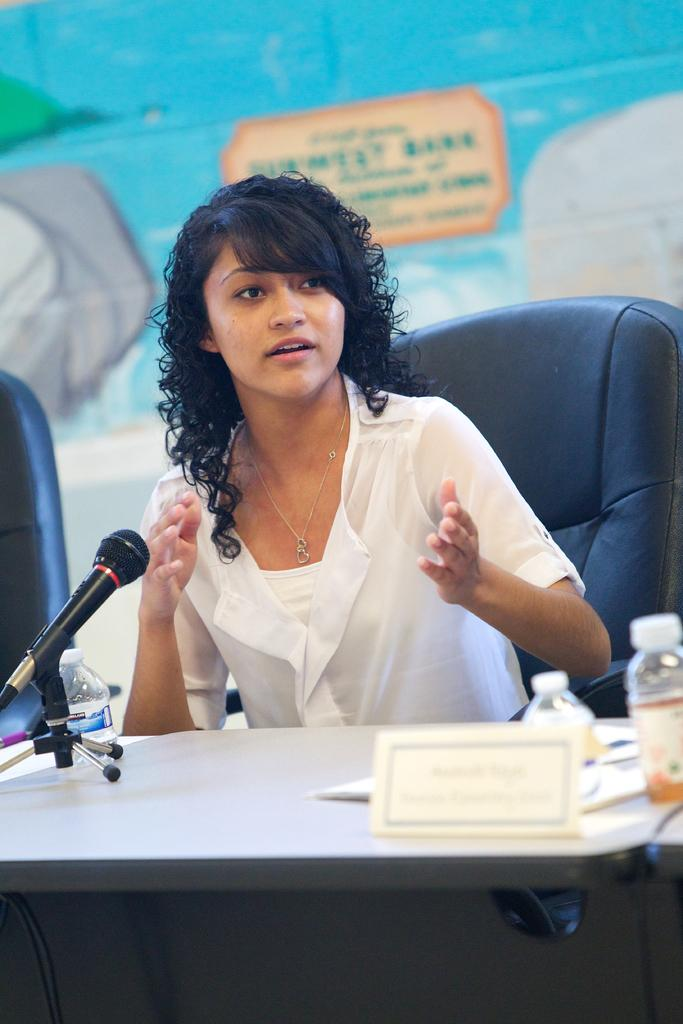Who is the main subject in the image? There is a woman in the image. What is the woman doing in the image? The woman is sitting on a chair. What is in front of the woman? There is a table in front of the woman. What objects can be seen on the table? There are 3 bottles and a mic on the table. What type of ink is the farmer using on the glass in the image? There is no farmer, ink, or glass present in the image. 